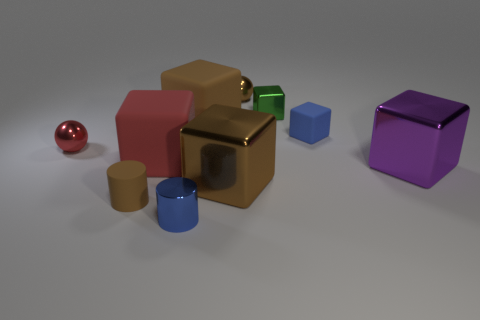Which objects in the image appear to have a reflective surface? In the image, several objects display reflective surfaces. These include the red sphere, the green and gold cubes, and the cylindrical objects, which show highlights and reflections on their surfaces. 